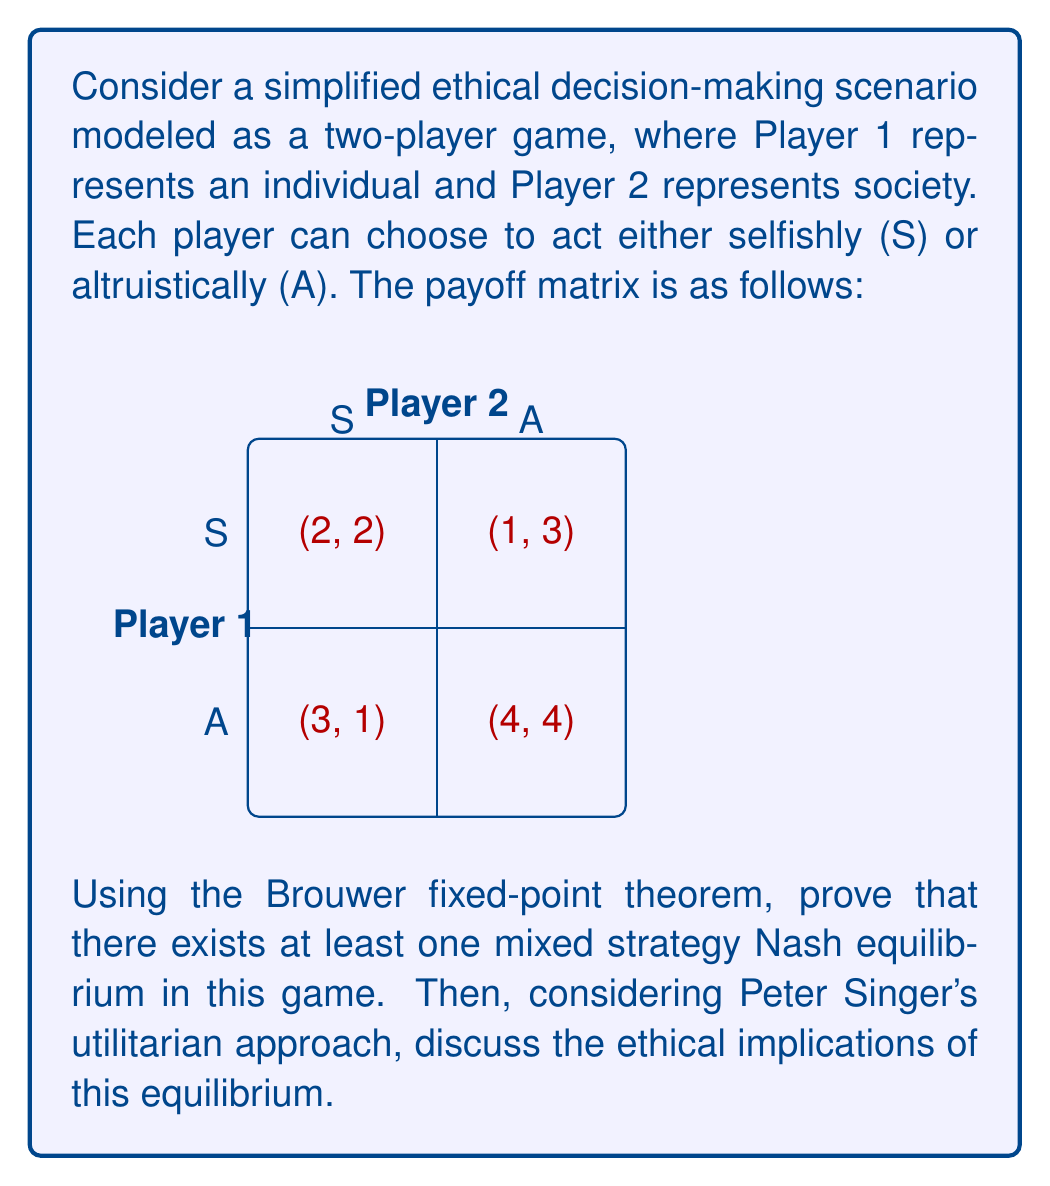Can you answer this question? Let's approach this step-by-step:

1) First, we need to understand the Brouwer fixed-point theorem. It states that for any continuous function $f$ from a compact convex set to itself, there is a point $x_0$ such that $f(x_0) = x_0$.

2) In game theory, we can use this theorem to prove the existence of mixed strategy Nash equilibria. Let's define our strategy space:

   Let $p$ be the probability that Player 1 chooses S, and $q$ be the probability that Player 2 chooses S.
   The strategy space is $[0,1] \times [0,1]$, which is compact and convex.

3) We can define a function $f: [0,1] \times [0,1] \to [0,1] \times [0,1]$ as follows:

   $f(p,q) = (p', q')$ where:
   $p' = \max(0, \min(1, p + E_1(S,q) - E_1(A,q)))$
   $q' = \max(0, \min(1, q + E_2(S,p) - E_2(A,p)))$

   Here, $E_i(X,y)$ is the expected payoff for player $i$ when they play $X$ and the other player uses mixed strategy $y$.

4) This function $f$ is continuous and maps the strategy space to itself. By the Brouwer fixed-point theorem, there must be a fixed point $(p^*, q^*)$ such that $f(p^*,q^*) = (p^*,q^*)$.

5) This fixed point $(p^*,q^*)$ is a Nash equilibrium, because at this point, neither player can improve their payoff by unilaterally changing their strategy.

6) To find this equilibrium, we can set up the indifference equations:

   For Player 1: $2q + 3(1-q) = 1q + 4(1-q)$
   For Player 2: $2p + 1(1-p) = 3p + 4(1-p)$

7) Solving these equations:
   $2q + 3 - 3q = q + 4 - 4q$
   $-q = 1 - 3q$
   $2q = 1$
   $q^* = 1/2$

   $2p + 1 - p = 3p + 4 - 4p$
   $p = 3$
   $p^* = 3/4$

8) Therefore, the mixed strategy Nash equilibrium is $(p^*, q^*) = (3/4, 1/2)$.

9) From Peter Singer's utilitarian perspective, we should consider the overall welfare. The expected payoff at this equilibrium is:

   $E = (3/4 * 1/2 * 2) + (3/4 * 1/2 * 1) + (1/4 * 1/2 * 3) + (1/4 * 1/2 * 4) = 2.125$

   This is lower than the payoff of (4, 4) if both players chose A, which would maximize overall welfare.

10) Singer would likely argue that this equilibrium is suboptimal from an ethical standpoint. He would advocate for choosing the strategy that produces the best outcomes for all affected parties, which in this case would be mutual altruism.
Answer: Mixed strategy Nash equilibrium: $(3/4, 1/2)$. Ethically suboptimal per Singer's utilitarianism; mutual altruism preferred. 